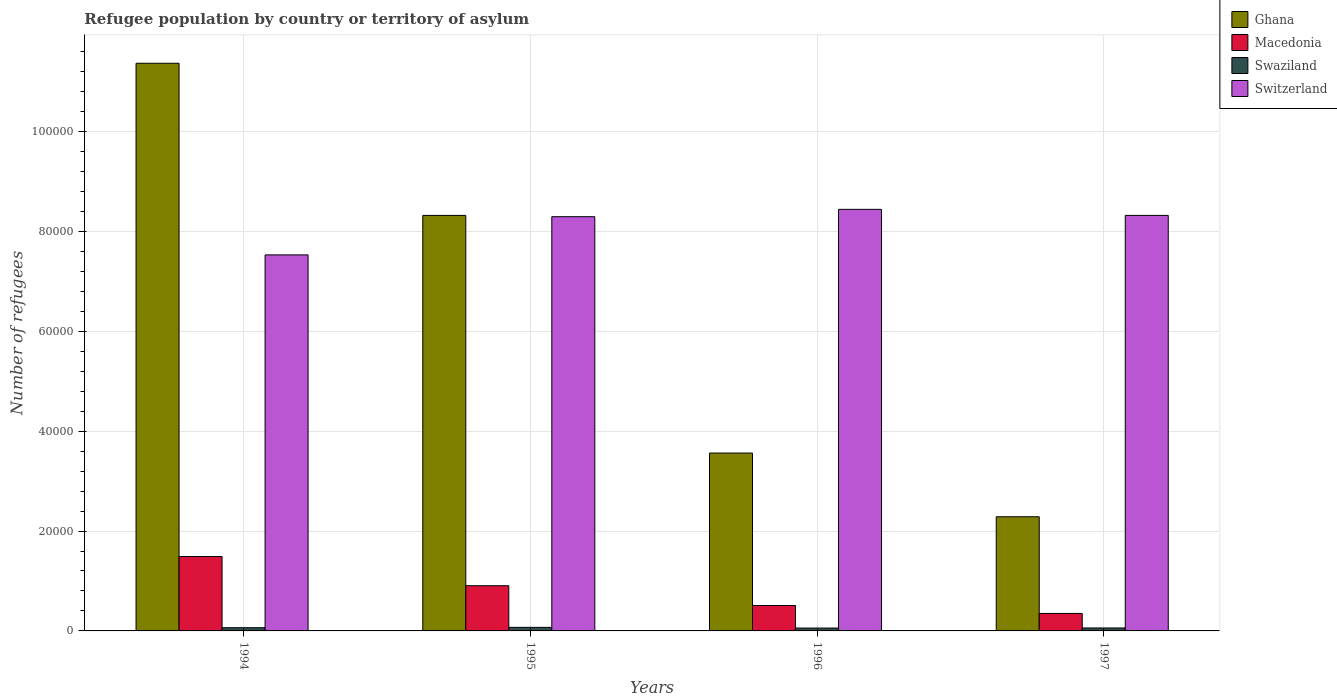How many different coloured bars are there?
Your response must be concise. 4. How many groups of bars are there?
Give a very brief answer. 4. Are the number of bars on each tick of the X-axis equal?
Keep it short and to the point. Yes. How many bars are there on the 3rd tick from the left?
Provide a short and direct response. 4. What is the label of the 2nd group of bars from the left?
Provide a succinct answer. 1995. What is the number of refugees in Macedonia in 1994?
Your answer should be very brief. 1.49e+04. Across all years, what is the maximum number of refugees in Macedonia?
Your answer should be compact. 1.49e+04. Across all years, what is the minimum number of refugees in Swaziland?
Give a very brief answer. 575. In which year was the number of refugees in Swaziland maximum?
Provide a short and direct response. 1995. In which year was the number of refugees in Macedonia minimum?
Your response must be concise. 1997. What is the total number of refugees in Ghana in the graph?
Provide a succinct answer. 2.55e+05. What is the difference between the number of refugees in Switzerland in 1995 and that in 1996?
Offer a terse response. -1470. What is the difference between the number of refugees in Swaziland in 1996 and the number of refugees in Ghana in 1994?
Keep it short and to the point. -1.13e+05. What is the average number of refugees in Switzerland per year?
Ensure brevity in your answer.  8.15e+04. In the year 1995, what is the difference between the number of refugees in Switzerland and number of refugees in Macedonia?
Your answer should be compact. 7.39e+04. What is the ratio of the number of refugees in Ghana in 1996 to that in 1997?
Your answer should be compact. 1.56. Is the difference between the number of refugees in Switzerland in 1994 and 1996 greater than the difference between the number of refugees in Macedonia in 1994 and 1996?
Offer a terse response. No. What is the difference between the highest and the second highest number of refugees in Switzerland?
Your answer should be very brief. 1210. What is the difference between the highest and the lowest number of refugees in Switzerland?
Your response must be concise. 9118. In how many years, is the number of refugees in Switzerland greater than the average number of refugees in Switzerland taken over all years?
Ensure brevity in your answer.  3. Is the sum of the number of refugees in Macedonia in 1994 and 1996 greater than the maximum number of refugees in Ghana across all years?
Your response must be concise. No. Is it the case that in every year, the sum of the number of refugees in Macedonia and number of refugees in Swaziland is greater than the sum of number of refugees in Ghana and number of refugees in Switzerland?
Keep it short and to the point. No. What does the 1st bar from the left in 1995 represents?
Your answer should be compact. Ghana. What does the 1st bar from the right in 1996 represents?
Provide a succinct answer. Switzerland. Is it the case that in every year, the sum of the number of refugees in Switzerland and number of refugees in Ghana is greater than the number of refugees in Swaziland?
Your answer should be compact. Yes. Are all the bars in the graph horizontal?
Keep it short and to the point. No. What is the difference between two consecutive major ticks on the Y-axis?
Ensure brevity in your answer.  2.00e+04. How many legend labels are there?
Your response must be concise. 4. How are the legend labels stacked?
Provide a succinct answer. Vertical. What is the title of the graph?
Give a very brief answer. Refugee population by country or territory of asylum. What is the label or title of the Y-axis?
Offer a very short reply. Number of refugees. What is the Number of refugees of Ghana in 1994?
Ensure brevity in your answer.  1.14e+05. What is the Number of refugees in Macedonia in 1994?
Provide a succinct answer. 1.49e+04. What is the Number of refugees of Swaziland in 1994?
Offer a very short reply. 643. What is the Number of refugees of Switzerland in 1994?
Give a very brief answer. 7.53e+04. What is the Number of refugees in Ghana in 1995?
Provide a short and direct response. 8.32e+04. What is the Number of refugees of Macedonia in 1995?
Offer a terse response. 9048. What is the Number of refugees of Swaziland in 1995?
Your answer should be compact. 712. What is the Number of refugees in Switzerland in 1995?
Ensure brevity in your answer.  8.29e+04. What is the Number of refugees in Ghana in 1996?
Provide a succinct answer. 3.56e+04. What is the Number of refugees in Macedonia in 1996?
Provide a short and direct response. 5089. What is the Number of refugees in Swaziland in 1996?
Offer a very short reply. 575. What is the Number of refugees of Switzerland in 1996?
Ensure brevity in your answer.  8.44e+04. What is the Number of refugees in Ghana in 1997?
Make the answer very short. 2.29e+04. What is the Number of refugees in Macedonia in 1997?
Keep it short and to the point. 3500. What is the Number of refugees of Swaziland in 1997?
Your answer should be compact. 592. What is the Number of refugees in Switzerland in 1997?
Offer a very short reply. 8.32e+04. Across all years, what is the maximum Number of refugees in Ghana?
Your answer should be compact. 1.14e+05. Across all years, what is the maximum Number of refugees in Macedonia?
Your answer should be very brief. 1.49e+04. Across all years, what is the maximum Number of refugees of Swaziland?
Your response must be concise. 712. Across all years, what is the maximum Number of refugees in Switzerland?
Provide a succinct answer. 8.44e+04. Across all years, what is the minimum Number of refugees in Ghana?
Keep it short and to the point. 2.29e+04. Across all years, what is the minimum Number of refugees of Macedonia?
Your answer should be compact. 3500. Across all years, what is the minimum Number of refugees in Swaziland?
Your answer should be compact. 575. Across all years, what is the minimum Number of refugees of Switzerland?
Make the answer very short. 7.53e+04. What is the total Number of refugees in Ghana in the graph?
Your response must be concise. 2.55e+05. What is the total Number of refugees in Macedonia in the graph?
Keep it short and to the point. 3.25e+04. What is the total Number of refugees of Swaziland in the graph?
Your answer should be compact. 2522. What is the total Number of refugees of Switzerland in the graph?
Your answer should be compact. 3.26e+05. What is the difference between the Number of refugees of Ghana in 1994 and that in 1995?
Give a very brief answer. 3.05e+04. What is the difference between the Number of refugees in Macedonia in 1994 and that in 1995?
Provide a short and direct response. 5843. What is the difference between the Number of refugees of Swaziland in 1994 and that in 1995?
Keep it short and to the point. -69. What is the difference between the Number of refugees of Switzerland in 1994 and that in 1995?
Offer a very short reply. -7648. What is the difference between the Number of refugees of Ghana in 1994 and that in 1996?
Give a very brief answer. 7.80e+04. What is the difference between the Number of refugees of Macedonia in 1994 and that in 1996?
Make the answer very short. 9802. What is the difference between the Number of refugees in Switzerland in 1994 and that in 1996?
Give a very brief answer. -9118. What is the difference between the Number of refugees of Ghana in 1994 and that in 1997?
Your response must be concise. 9.08e+04. What is the difference between the Number of refugees of Macedonia in 1994 and that in 1997?
Offer a terse response. 1.14e+04. What is the difference between the Number of refugees of Swaziland in 1994 and that in 1997?
Your answer should be compact. 51. What is the difference between the Number of refugees of Switzerland in 1994 and that in 1997?
Offer a very short reply. -7908. What is the difference between the Number of refugees in Ghana in 1995 and that in 1996?
Ensure brevity in your answer.  4.76e+04. What is the difference between the Number of refugees in Macedonia in 1995 and that in 1996?
Give a very brief answer. 3959. What is the difference between the Number of refugees in Swaziland in 1995 and that in 1996?
Your answer should be very brief. 137. What is the difference between the Number of refugees of Switzerland in 1995 and that in 1996?
Your answer should be compact. -1470. What is the difference between the Number of refugees in Ghana in 1995 and that in 1997?
Your answer should be compact. 6.03e+04. What is the difference between the Number of refugees of Macedonia in 1995 and that in 1997?
Keep it short and to the point. 5548. What is the difference between the Number of refugees of Swaziland in 1995 and that in 1997?
Your answer should be very brief. 120. What is the difference between the Number of refugees in Switzerland in 1995 and that in 1997?
Offer a terse response. -260. What is the difference between the Number of refugees in Ghana in 1996 and that in 1997?
Offer a very short reply. 1.28e+04. What is the difference between the Number of refugees in Macedonia in 1996 and that in 1997?
Give a very brief answer. 1589. What is the difference between the Number of refugees in Swaziland in 1996 and that in 1997?
Give a very brief answer. -17. What is the difference between the Number of refugees in Switzerland in 1996 and that in 1997?
Your response must be concise. 1210. What is the difference between the Number of refugees in Ghana in 1994 and the Number of refugees in Macedonia in 1995?
Make the answer very short. 1.05e+05. What is the difference between the Number of refugees of Ghana in 1994 and the Number of refugees of Swaziland in 1995?
Offer a very short reply. 1.13e+05. What is the difference between the Number of refugees in Ghana in 1994 and the Number of refugees in Switzerland in 1995?
Offer a very short reply. 3.07e+04. What is the difference between the Number of refugees in Macedonia in 1994 and the Number of refugees in Swaziland in 1995?
Provide a succinct answer. 1.42e+04. What is the difference between the Number of refugees in Macedonia in 1994 and the Number of refugees in Switzerland in 1995?
Your response must be concise. -6.81e+04. What is the difference between the Number of refugees of Swaziland in 1994 and the Number of refugees of Switzerland in 1995?
Your answer should be very brief. -8.23e+04. What is the difference between the Number of refugees of Ghana in 1994 and the Number of refugees of Macedonia in 1996?
Give a very brief answer. 1.09e+05. What is the difference between the Number of refugees in Ghana in 1994 and the Number of refugees in Swaziland in 1996?
Keep it short and to the point. 1.13e+05. What is the difference between the Number of refugees in Ghana in 1994 and the Number of refugees in Switzerland in 1996?
Keep it short and to the point. 2.93e+04. What is the difference between the Number of refugees of Macedonia in 1994 and the Number of refugees of Swaziland in 1996?
Ensure brevity in your answer.  1.43e+04. What is the difference between the Number of refugees of Macedonia in 1994 and the Number of refugees of Switzerland in 1996?
Give a very brief answer. -6.95e+04. What is the difference between the Number of refugees of Swaziland in 1994 and the Number of refugees of Switzerland in 1996?
Your answer should be compact. -8.38e+04. What is the difference between the Number of refugees in Ghana in 1994 and the Number of refugees in Macedonia in 1997?
Your answer should be compact. 1.10e+05. What is the difference between the Number of refugees in Ghana in 1994 and the Number of refugees in Swaziland in 1997?
Your response must be concise. 1.13e+05. What is the difference between the Number of refugees in Ghana in 1994 and the Number of refugees in Switzerland in 1997?
Ensure brevity in your answer.  3.05e+04. What is the difference between the Number of refugees of Macedonia in 1994 and the Number of refugees of Swaziland in 1997?
Give a very brief answer. 1.43e+04. What is the difference between the Number of refugees in Macedonia in 1994 and the Number of refugees in Switzerland in 1997?
Offer a very short reply. -6.83e+04. What is the difference between the Number of refugees in Swaziland in 1994 and the Number of refugees in Switzerland in 1997?
Provide a short and direct response. -8.26e+04. What is the difference between the Number of refugees of Ghana in 1995 and the Number of refugees of Macedonia in 1996?
Provide a succinct answer. 7.81e+04. What is the difference between the Number of refugees in Ghana in 1995 and the Number of refugees in Swaziland in 1996?
Your answer should be compact. 8.26e+04. What is the difference between the Number of refugees of Ghana in 1995 and the Number of refugees of Switzerland in 1996?
Offer a terse response. -1213. What is the difference between the Number of refugees of Macedonia in 1995 and the Number of refugees of Swaziland in 1996?
Your answer should be compact. 8473. What is the difference between the Number of refugees in Macedonia in 1995 and the Number of refugees in Switzerland in 1996?
Your answer should be very brief. -7.54e+04. What is the difference between the Number of refugees of Swaziland in 1995 and the Number of refugees of Switzerland in 1996?
Ensure brevity in your answer.  -8.37e+04. What is the difference between the Number of refugees of Ghana in 1995 and the Number of refugees of Macedonia in 1997?
Ensure brevity in your answer.  7.97e+04. What is the difference between the Number of refugees in Ghana in 1995 and the Number of refugees in Swaziland in 1997?
Make the answer very short. 8.26e+04. What is the difference between the Number of refugees of Ghana in 1995 and the Number of refugees of Switzerland in 1997?
Provide a short and direct response. -3. What is the difference between the Number of refugees in Macedonia in 1995 and the Number of refugees in Swaziland in 1997?
Your answer should be very brief. 8456. What is the difference between the Number of refugees of Macedonia in 1995 and the Number of refugees of Switzerland in 1997?
Your response must be concise. -7.42e+04. What is the difference between the Number of refugees of Swaziland in 1995 and the Number of refugees of Switzerland in 1997?
Provide a short and direct response. -8.25e+04. What is the difference between the Number of refugees in Ghana in 1996 and the Number of refugees in Macedonia in 1997?
Your answer should be compact. 3.21e+04. What is the difference between the Number of refugees of Ghana in 1996 and the Number of refugees of Swaziland in 1997?
Your answer should be very brief. 3.50e+04. What is the difference between the Number of refugees of Ghana in 1996 and the Number of refugees of Switzerland in 1997?
Provide a succinct answer. -4.76e+04. What is the difference between the Number of refugees of Macedonia in 1996 and the Number of refugees of Swaziland in 1997?
Provide a short and direct response. 4497. What is the difference between the Number of refugees of Macedonia in 1996 and the Number of refugees of Switzerland in 1997?
Make the answer very short. -7.81e+04. What is the difference between the Number of refugees in Swaziland in 1996 and the Number of refugees in Switzerland in 1997?
Your answer should be compact. -8.26e+04. What is the average Number of refugees in Ghana per year?
Offer a very short reply. 6.38e+04. What is the average Number of refugees of Macedonia per year?
Your answer should be very brief. 8132. What is the average Number of refugees of Swaziland per year?
Your answer should be compact. 630.5. What is the average Number of refugees in Switzerland per year?
Provide a short and direct response. 8.15e+04. In the year 1994, what is the difference between the Number of refugees of Ghana and Number of refugees of Macedonia?
Your response must be concise. 9.88e+04. In the year 1994, what is the difference between the Number of refugees of Ghana and Number of refugees of Swaziland?
Ensure brevity in your answer.  1.13e+05. In the year 1994, what is the difference between the Number of refugees in Ghana and Number of refugees in Switzerland?
Provide a short and direct response. 3.84e+04. In the year 1994, what is the difference between the Number of refugees of Macedonia and Number of refugees of Swaziland?
Your response must be concise. 1.42e+04. In the year 1994, what is the difference between the Number of refugees of Macedonia and Number of refugees of Switzerland?
Ensure brevity in your answer.  -6.04e+04. In the year 1994, what is the difference between the Number of refugees of Swaziland and Number of refugees of Switzerland?
Give a very brief answer. -7.47e+04. In the year 1995, what is the difference between the Number of refugees in Ghana and Number of refugees in Macedonia?
Provide a succinct answer. 7.42e+04. In the year 1995, what is the difference between the Number of refugees of Ghana and Number of refugees of Swaziland?
Your response must be concise. 8.25e+04. In the year 1995, what is the difference between the Number of refugees of Ghana and Number of refugees of Switzerland?
Provide a succinct answer. 257. In the year 1995, what is the difference between the Number of refugees in Macedonia and Number of refugees in Swaziland?
Keep it short and to the point. 8336. In the year 1995, what is the difference between the Number of refugees in Macedonia and Number of refugees in Switzerland?
Offer a terse response. -7.39e+04. In the year 1995, what is the difference between the Number of refugees of Swaziland and Number of refugees of Switzerland?
Provide a short and direct response. -8.22e+04. In the year 1996, what is the difference between the Number of refugees of Ghana and Number of refugees of Macedonia?
Make the answer very short. 3.05e+04. In the year 1996, what is the difference between the Number of refugees in Ghana and Number of refugees in Swaziland?
Provide a succinct answer. 3.50e+04. In the year 1996, what is the difference between the Number of refugees of Ghana and Number of refugees of Switzerland?
Provide a short and direct response. -4.88e+04. In the year 1996, what is the difference between the Number of refugees of Macedonia and Number of refugees of Swaziland?
Your response must be concise. 4514. In the year 1996, what is the difference between the Number of refugees of Macedonia and Number of refugees of Switzerland?
Offer a terse response. -7.93e+04. In the year 1996, what is the difference between the Number of refugees in Swaziland and Number of refugees in Switzerland?
Ensure brevity in your answer.  -8.38e+04. In the year 1997, what is the difference between the Number of refugees in Ghana and Number of refugees in Macedonia?
Offer a very short reply. 1.94e+04. In the year 1997, what is the difference between the Number of refugees in Ghana and Number of refugees in Swaziland?
Your response must be concise. 2.23e+04. In the year 1997, what is the difference between the Number of refugees in Ghana and Number of refugees in Switzerland?
Your response must be concise. -6.03e+04. In the year 1997, what is the difference between the Number of refugees in Macedonia and Number of refugees in Swaziland?
Provide a succinct answer. 2908. In the year 1997, what is the difference between the Number of refugees of Macedonia and Number of refugees of Switzerland?
Your answer should be compact. -7.97e+04. In the year 1997, what is the difference between the Number of refugees in Swaziland and Number of refugees in Switzerland?
Provide a succinct answer. -8.26e+04. What is the ratio of the Number of refugees in Ghana in 1994 to that in 1995?
Your response must be concise. 1.37. What is the ratio of the Number of refugees in Macedonia in 1994 to that in 1995?
Offer a very short reply. 1.65. What is the ratio of the Number of refugees of Swaziland in 1994 to that in 1995?
Keep it short and to the point. 0.9. What is the ratio of the Number of refugees in Switzerland in 1994 to that in 1995?
Your answer should be compact. 0.91. What is the ratio of the Number of refugees in Ghana in 1994 to that in 1996?
Ensure brevity in your answer.  3.19. What is the ratio of the Number of refugees of Macedonia in 1994 to that in 1996?
Your answer should be compact. 2.93. What is the ratio of the Number of refugees in Swaziland in 1994 to that in 1996?
Provide a succinct answer. 1.12. What is the ratio of the Number of refugees of Switzerland in 1994 to that in 1996?
Your response must be concise. 0.89. What is the ratio of the Number of refugees of Ghana in 1994 to that in 1997?
Make the answer very short. 4.97. What is the ratio of the Number of refugees of Macedonia in 1994 to that in 1997?
Your response must be concise. 4.25. What is the ratio of the Number of refugees of Swaziland in 1994 to that in 1997?
Your response must be concise. 1.09. What is the ratio of the Number of refugees in Switzerland in 1994 to that in 1997?
Your answer should be compact. 0.91. What is the ratio of the Number of refugees of Ghana in 1995 to that in 1996?
Offer a terse response. 2.34. What is the ratio of the Number of refugees of Macedonia in 1995 to that in 1996?
Your answer should be very brief. 1.78. What is the ratio of the Number of refugees in Swaziland in 1995 to that in 1996?
Keep it short and to the point. 1.24. What is the ratio of the Number of refugees in Switzerland in 1995 to that in 1996?
Your response must be concise. 0.98. What is the ratio of the Number of refugees of Ghana in 1995 to that in 1997?
Offer a very short reply. 3.64. What is the ratio of the Number of refugees of Macedonia in 1995 to that in 1997?
Offer a terse response. 2.59. What is the ratio of the Number of refugees in Swaziland in 1995 to that in 1997?
Your answer should be very brief. 1.2. What is the ratio of the Number of refugees of Switzerland in 1995 to that in 1997?
Provide a short and direct response. 1. What is the ratio of the Number of refugees in Ghana in 1996 to that in 1997?
Your answer should be very brief. 1.56. What is the ratio of the Number of refugees of Macedonia in 1996 to that in 1997?
Make the answer very short. 1.45. What is the ratio of the Number of refugees of Swaziland in 1996 to that in 1997?
Your answer should be compact. 0.97. What is the ratio of the Number of refugees in Switzerland in 1996 to that in 1997?
Make the answer very short. 1.01. What is the difference between the highest and the second highest Number of refugees of Ghana?
Make the answer very short. 3.05e+04. What is the difference between the highest and the second highest Number of refugees in Macedonia?
Provide a succinct answer. 5843. What is the difference between the highest and the second highest Number of refugees of Switzerland?
Your answer should be very brief. 1210. What is the difference between the highest and the lowest Number of refugees in Ghana?
Ensure brevity in your answer.  9.08e+04. What is the difference between the highest and the lowest Number of refugees in Macedonia?
Provide a succinct answer. 1.14e+04. What is the difference between the highest and the lowest Number of refugees of Swaziland?
Your answer should be very brief. 137. What is the difference between the highest and the lowest Number of refugees in Switzerland?
Provide a short and direct response. 9118. 